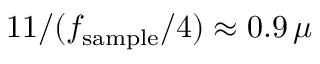<formula> <loc_0><loc_0><loc_500><loc_500>1 1 / ( f _ { s a m p l e } / 4 ) \approx 0 . 9 \, \mu</formula> 